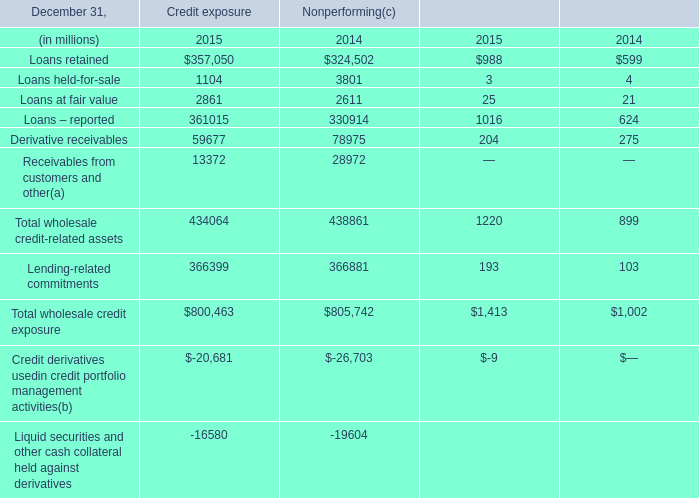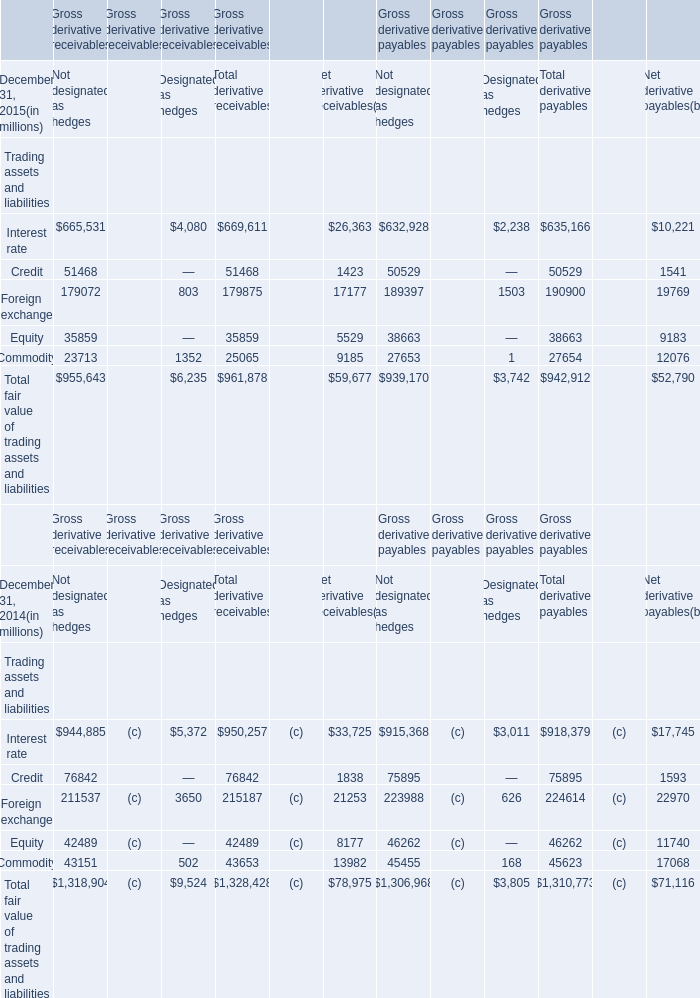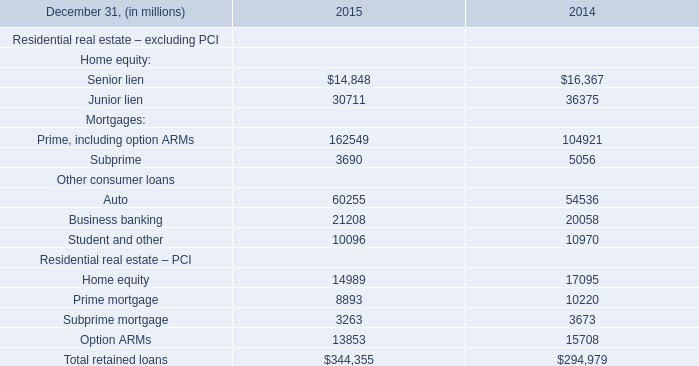what's the total amount of Derivative receivables of Credit exposure 2015, and Subprime mortgage Residential real estate – PCI of 2014 ? 
Computations: (59677.0 + 3673.0)
Answer: 63350.0. 